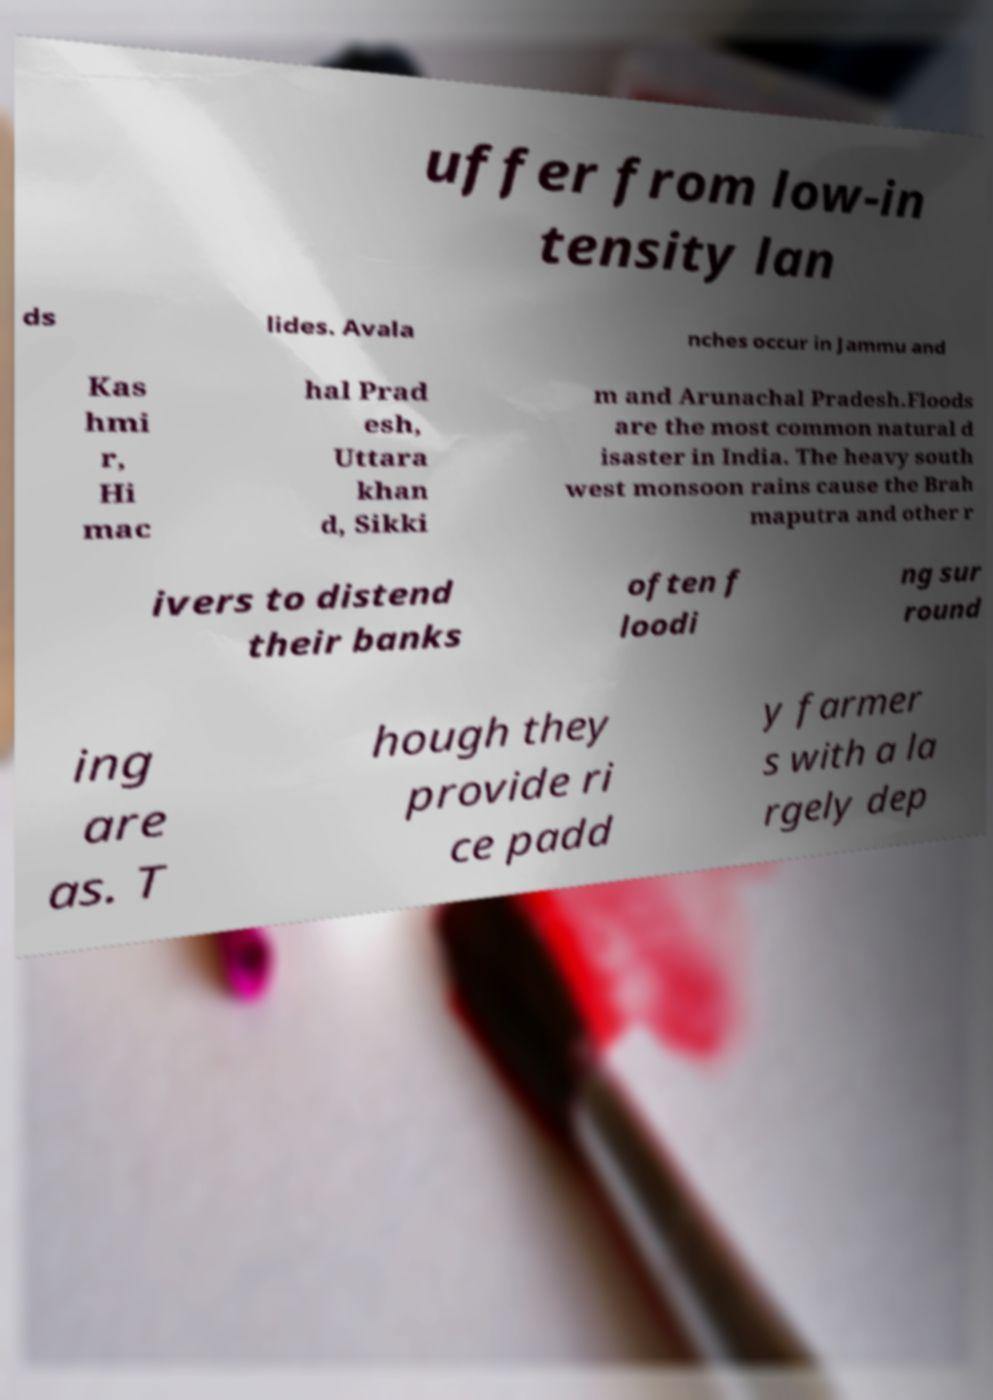There's text embedded in this image that I need extracted. Can you transcribe it verbatim? uffer from low-in tensity lan ds lides. Avala nches occur in Jammu and Kas hmi r, Hi mac hal Prad esh, Uttara khan d, Sikki m and Arunachal Pradesh.Floods are the most common natural d isaster in India. The heavy south west monsoon rains cause the Brah maputra and other r ivers to distend their banks often f loodi ng sur round ing are as. T hough they provide ri ce padd y farmer s with a la rgely dep 